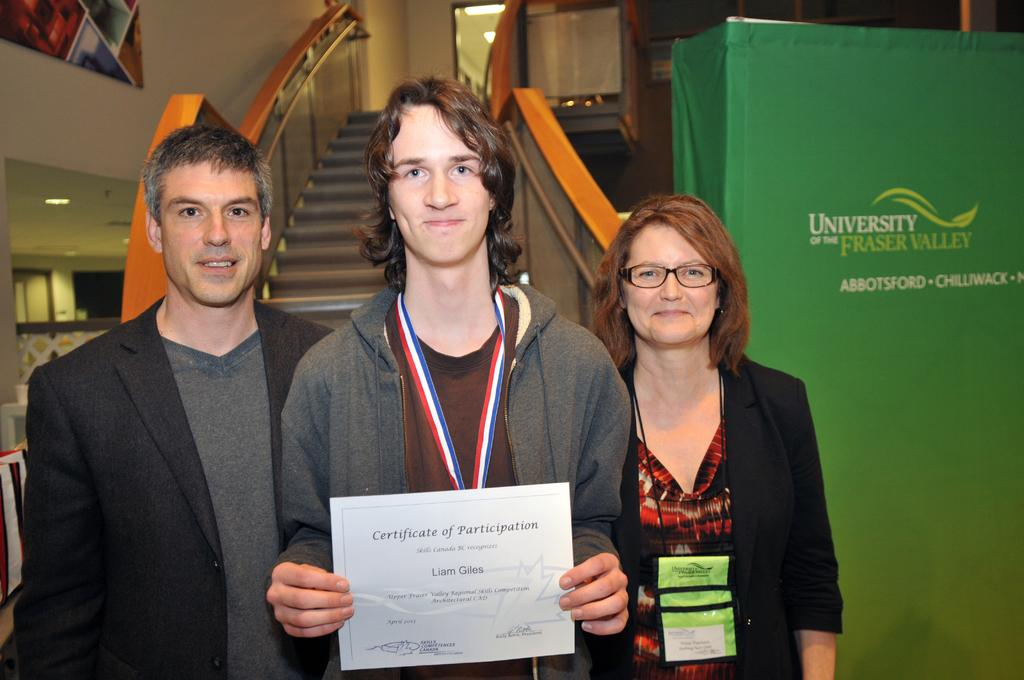<image>
Relay a brief, clear account of the picture shown. Boy holding a Certificate of Participation posing with his parents. 